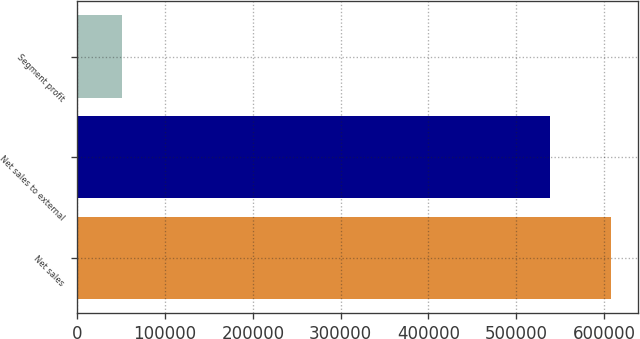Convert chart. <chart><loc_0><loc_0><loc_500><loc_500><bar_chart><fcel>Net sales<fcel>Net sales to external<fcel>Segment profit<nl><fcel>607836<fcel>538953<fcel>50635<nl></chart> 